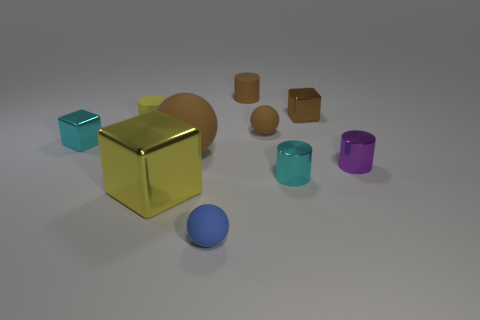Subtract all big yellow metal blocks. How many blocks are left? 2 Subtract all cylinders. How many objects are left? 6 Add 3 large things. How many large things exist? 5 Subtract all brown spheres. How many spheres are left? 1 Subtract 0 purple blocks. How many objects are left? 10 Subtract 1 balls. How many balls are left? 2 Subtract all red cylinders. Subtract all blue spheres. How many cylinders are left? 4 Subtract all purple cylinders. How many red spheres are left? 0 Subtract all green matte cylinders. Subtract all tiny brown metallic objects. How many objects are left? 9 Add 3 shiny objects. How many shiny objects are left? 8 